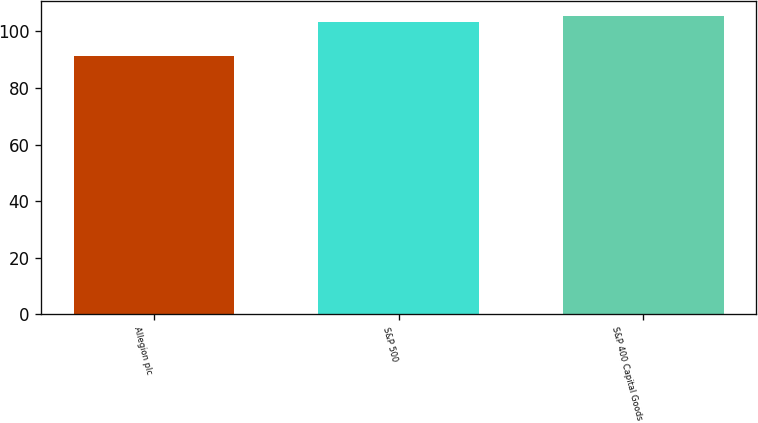Convert chart. <chart><loc_0><loc_0><loc_500><loc_500><bar_chart><fcel>Allegion plc<fcel>S&P 500<fcel>S&P 400 Capital Goods<nl><fcel>91.16<fcel>103.44<fcel>105.46<nl></chart> 